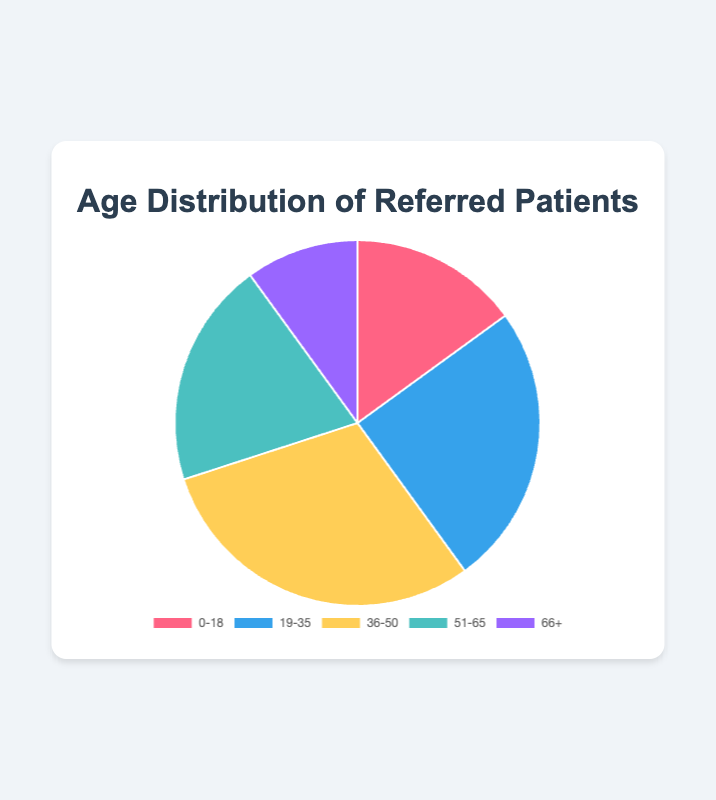Which age group has the highest percentage of referred patients? The figure shows that each age group is represented as a slice of the pie chart, with the percentage labeled. By observing the chart, the age group 36-50 has the largest slice, which shows 30%.
Answer: 36-50 Which age group has the lowest percentage of referred patients? The figure shows that each age group is represented as a slice of the pie chart, with the percentage labeled. By observing the chart, the smallest slice is for the age group 66+, which shows 10%.
Answer: 66+ What is the combined percentage of patients referred in the age groups 0-18 and 66+? The figure shows the individual percentages for each age group. For 0-18, it is 15%, and for 66+, it is 10%. Summing these percentages results in 15% + 10% = 25%.
Answer: 25% How much more is the percentage of patients referred in the age group 36-50 compared to 19-35? The figure shows the individual percentages for each age group. For 36-50, it is 30%, and for 19-35, it is 25%. The difference is 30% - 25% = 5%.
Answer: 5% What is the percentage of patients referred in the two age groups with the most referrals combined? The figure shows the individual percentages for each age group. The two groups with the most referrals are 36-50 (30%) and 19-35 (25%). Summing these percentages results in 30% + 25% = 55%.
Answer: 55% Which age range has a percentage closer to 20%? The figure shows that the age group 51-65 has a percentage of 20%, which is exactly 20%. Observation of the other percentages (15%, 25%, 30%, and 10%) confirms that none of these are as close to 20% as the 51-65 age group.
Answer: 51-65 Is the total percentage of referred patients in the age groups 36-50 and 66+ greater than that in the age groups 19-35 and 0-18? The percentages in the age groups 36-50 and 66+ are 30% and 10%, respectively, summing to 40%. For the age groups 19-35 and 0-18, the percentages are 25% and 15%, respectively, also summing to 40%. Thus, 40% is equal to 40%.
Answer: No What is the average percentage of referred patients across all age groups? The figure shows the individual percentages for each age group. To find the average, sum all percentages: 15% + 25% + 30% + 20% + 10% = 100%. Then, divide by the number of age groups, which is 5: 100% / 5 = 20%.
Answer: 20% Based on the colors used in the pie chart, which age group is represented by the blue segment? The figure indicates blue represents the age group 19-35. Observation of the portions and the corresponding labels confirms this.
Answer: 19-35 